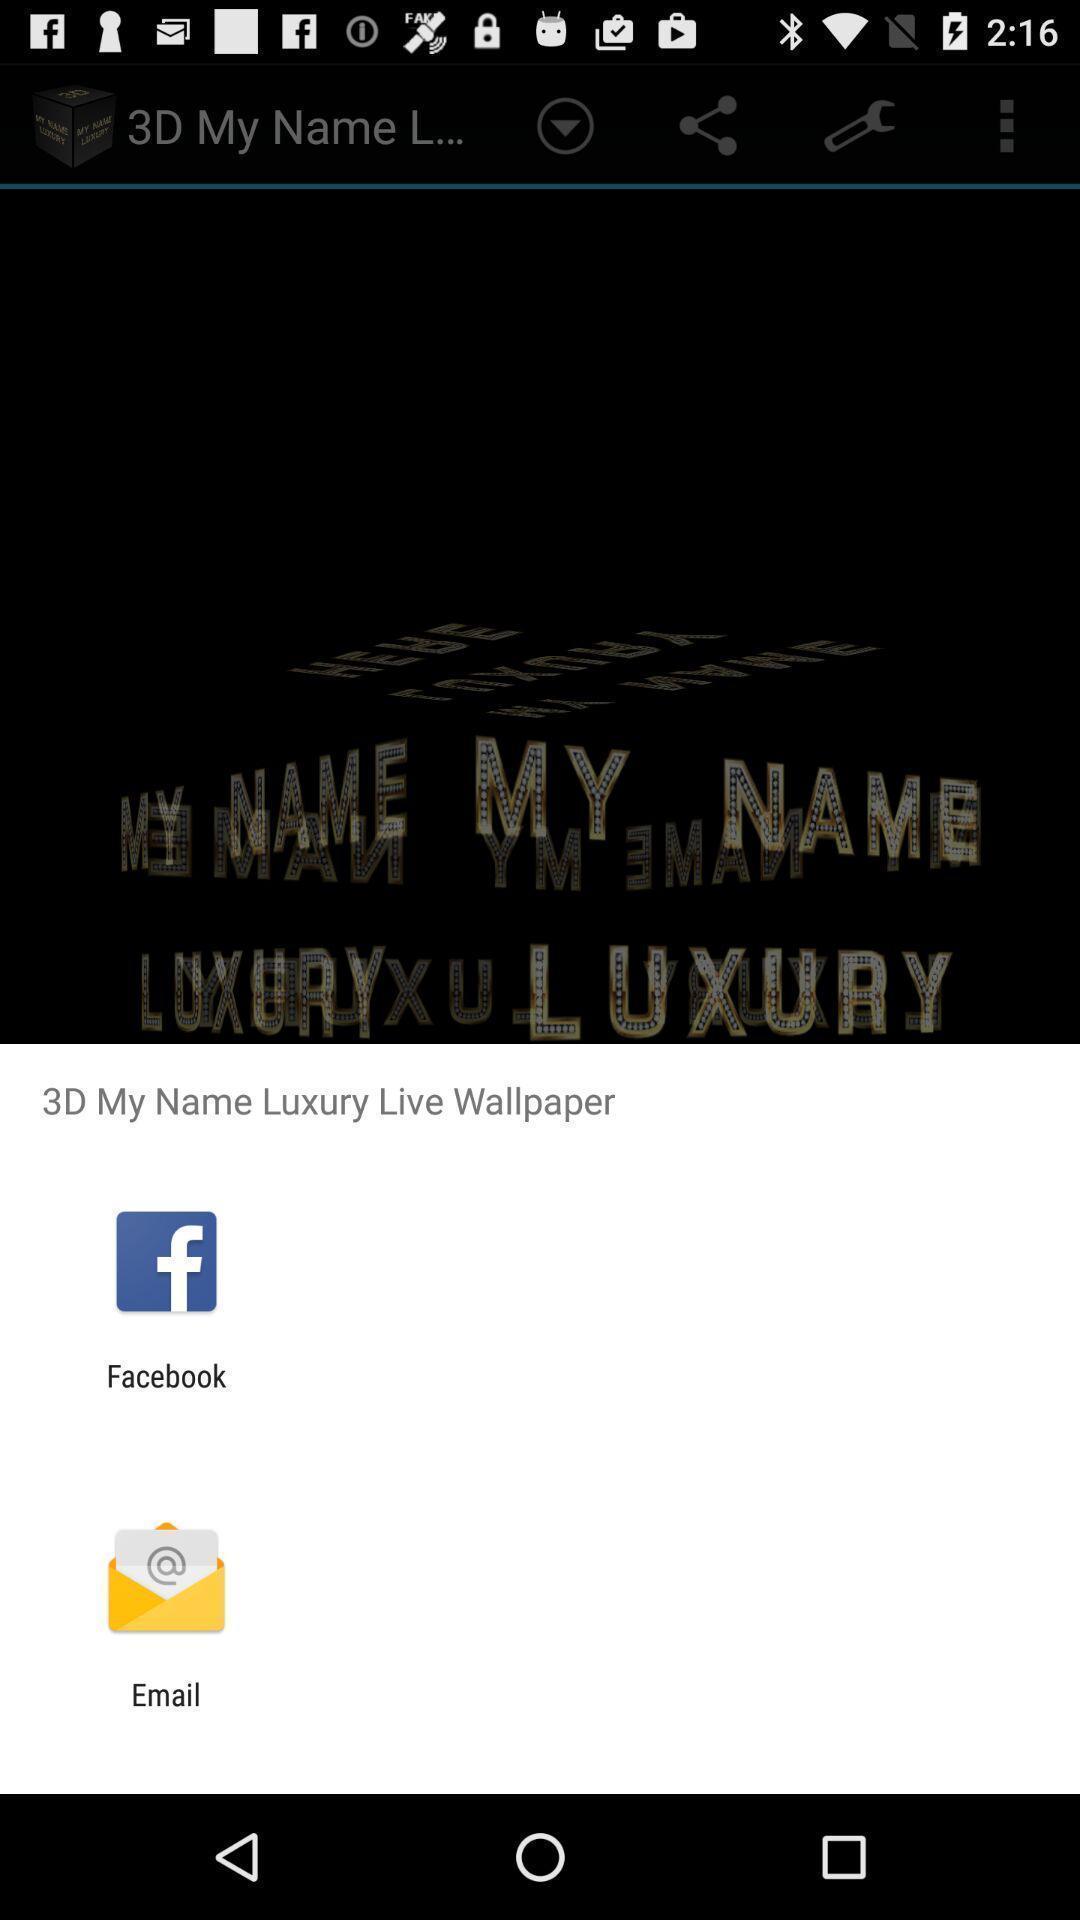Please provide a description for this image. Popup to share the wallpaper application. 